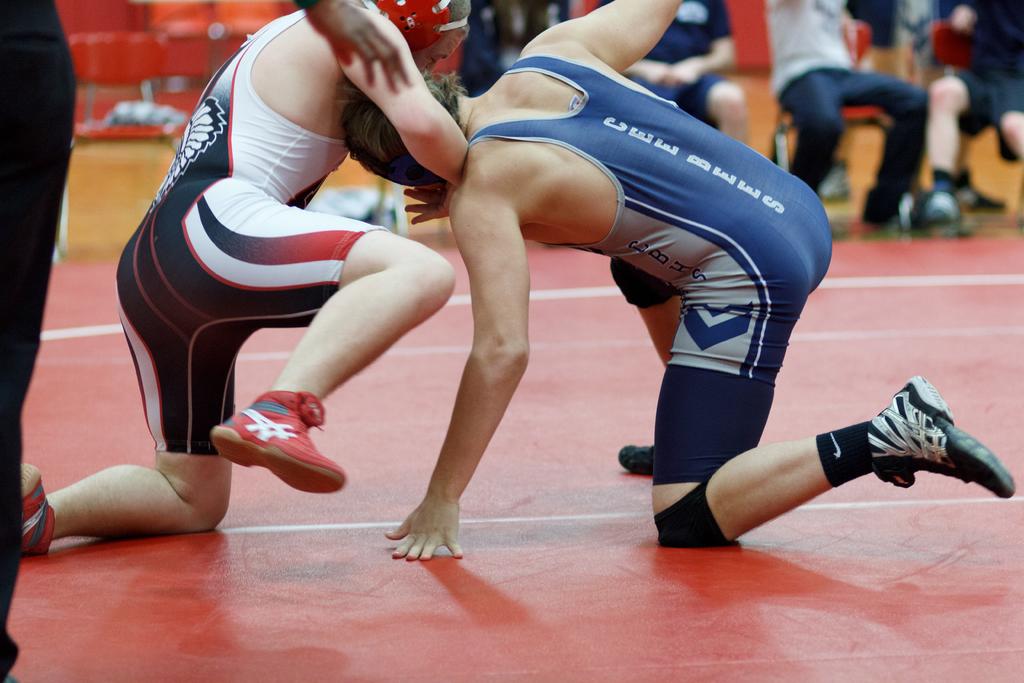What does the blue wrestler's jersey read on the back?
Your answer should be very brief. Cee bees. 